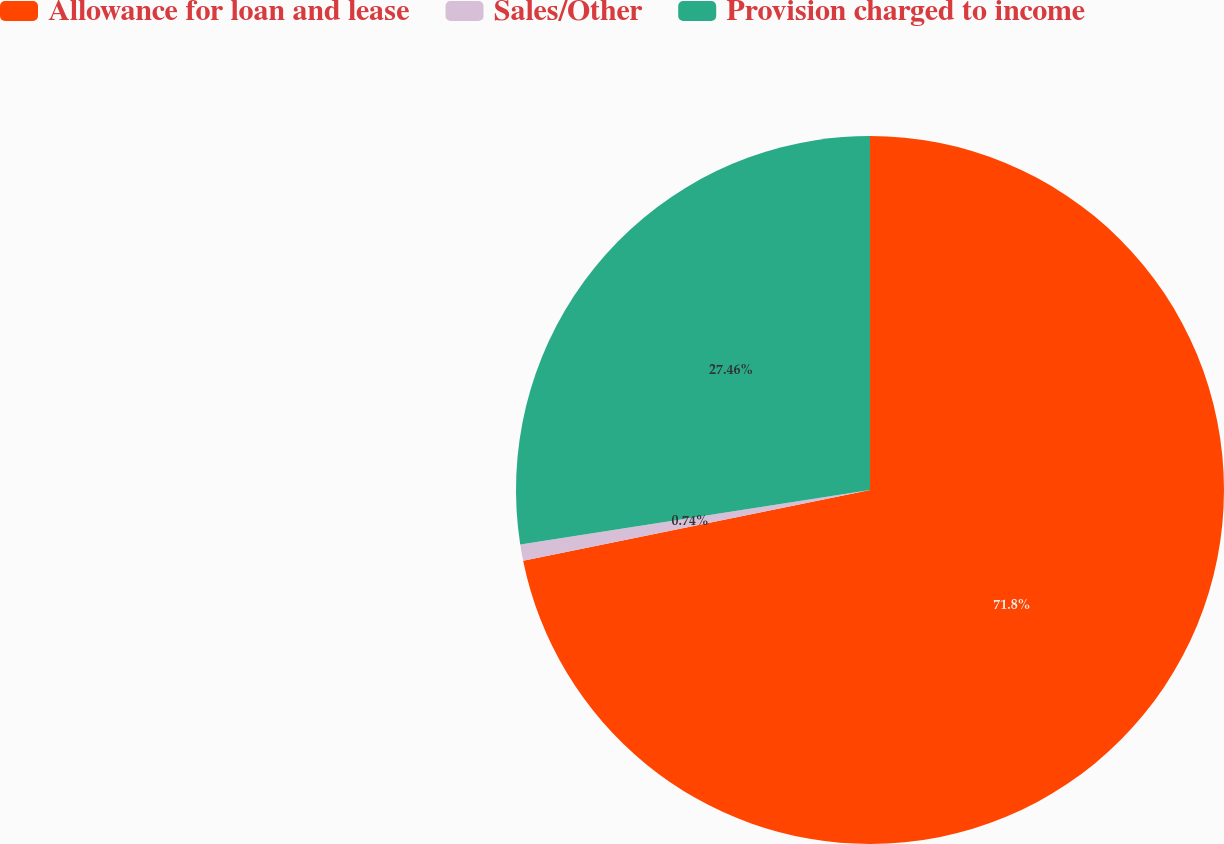Convert chart. <chart><loc_0><loc_0><loc_500><loc_500><pie_chart><fcel>Allowance for loan and lease<fcel>Sales/Other<fcel>Provision charged to income<nl><fcel>71.8%<fcel>0.74%<fcel>27.46%<nl></chart> 